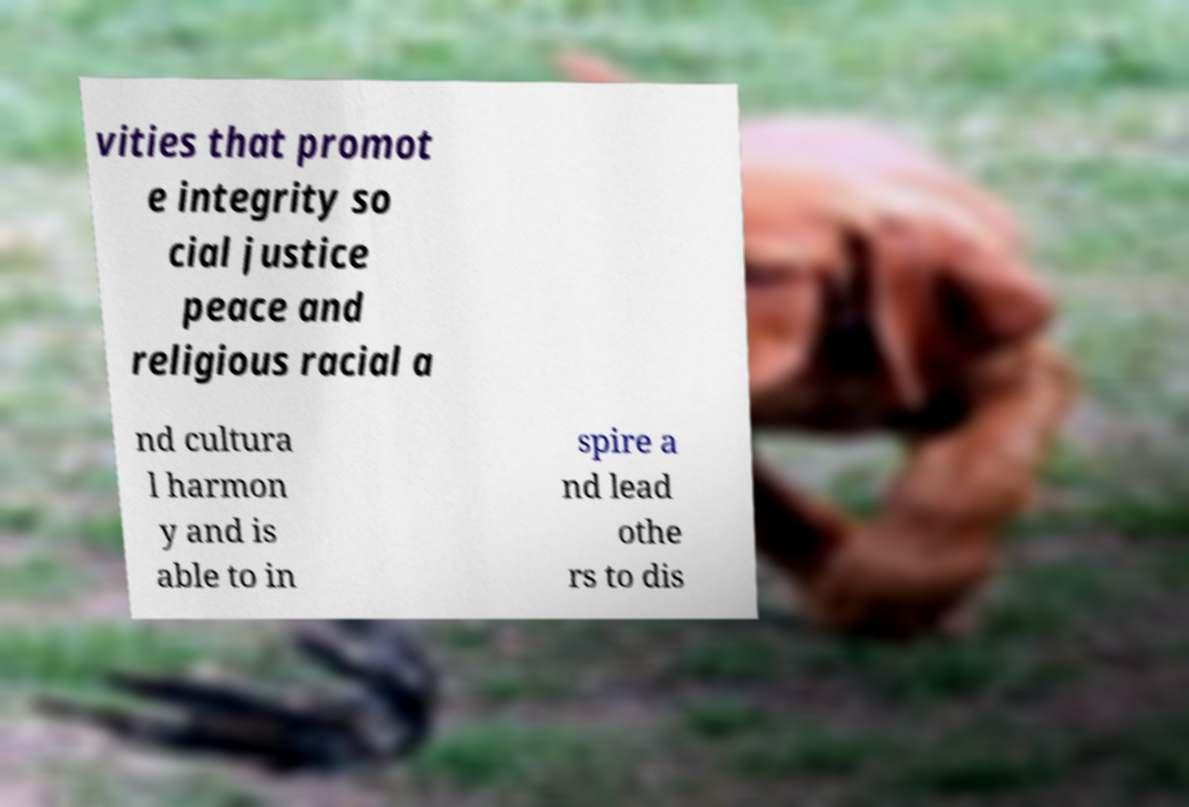Can you read and provide the text displayed in the image?This photo seems to have some interesting text. Can you extract and type it out for me? vities that promot e integrity so cial justice peace and religious racial a nd cultura l harmon y and is able to in spire a nd lead othe rs to dis 